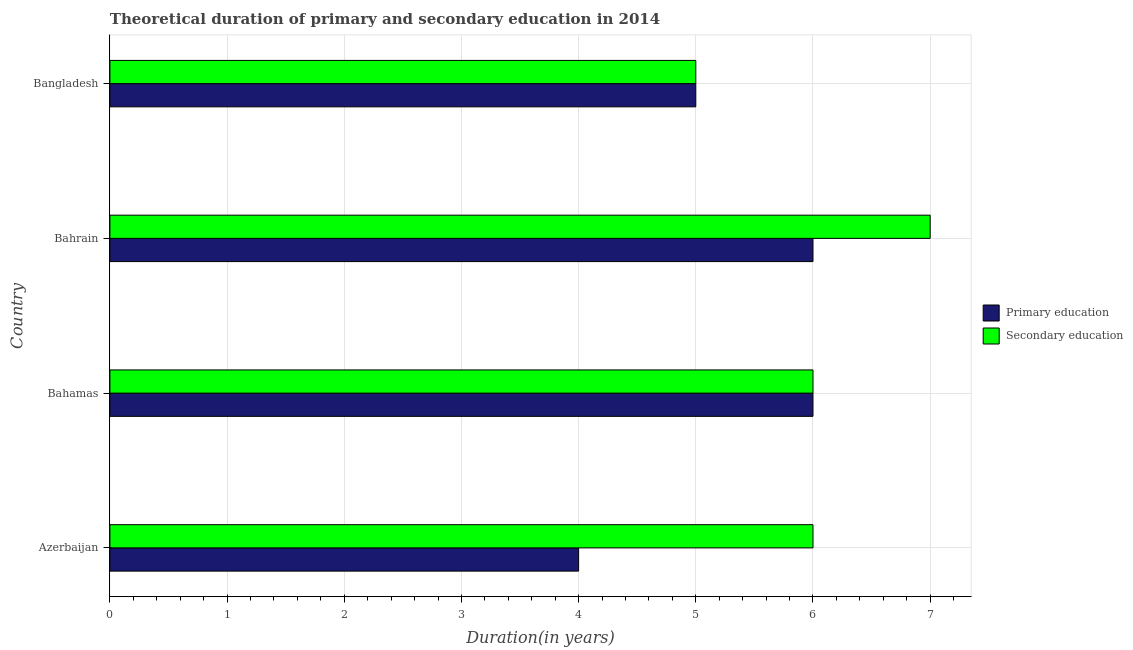How many different coloured bars are there?
Ensure brevity in your answer.  2. How many groups of bars are there?
Your answer should be compact. 4. Are the number of bars on each tick of the Y-axis equal?
Your answer should be compact. Yes. How many bars are there on the 2nd tick from the bottom?
Your answer should be compact. 2. What is the label of the 2nd group of bars from the top?
Offer a terse response. Bahrain. What is the duration of primary education in Bangladesh?
Your response must be concise. 5. Across all countries, what is the maximum duration of secondary education?
Your answer should be very brief. 7. Across all countries, what is the minimum duration of primary education?
Ensure brevity in your answer.  4. In which country was the duration of secondary education maximum?
Your response must be concise. Bahrain. In which country was the duration of primary education minimum?
Your answer should be compact. Azerbaijan. What is the total duration of secondary education in the graph?
Your response must be concise. 24. What is the difference between the duration of primary education in Bahamas and that in Bangladesh?
Your answer should be very brief. 1. What is the difference between the duration of primary education in Bahrain and the duration of secondary education in Bahamas?
Provide a short and direct response. 0. What is the average duration of primary education per country?
Provide a succinct answer. 5.25. In how many countries, is the duration of primary education greater than 0.4 years?
Keep it short and to the point. 4. What is the difference between the highest and the second highest duration of primary education?
Provide a short and direct response. 0. What is the difference between the highest and the lowest duration of secondary education?
Provide a short and direct response. 2. In how many countries, is the duration of secondary education greater than the average duration of secondary education taken over all countries?
Give a very brief answer. 1. Is the sum of the duration of secondary education in Bahamas and Bahrain greater than the maximum duration of primary education across all countries?
Keep it short and to the point. Yes. What does the 1st bar from the top in Azerbaijan represents?
Keep it short and to the point. Secondary education. What is the difference between two consecutive major ticks on the X-axis?
Make the answer very short. 1. Are the values on the major ticks of X-axis written in scientific E-notation?
Give a very brief answer. No. Does the graph contain grids?
Keep it short and to the point. Yes. Where does the legend appear in the graph?
Offer a terse response. Center right. How many legend labels are there?
Give a very brief answer. 2. What is the title of the graph?
Offer a very short reply. Theoretical duration of primary and secondary education in 2014. Does "Canada" appear as one of the legend labels in the graph?
Provide a short and direct response. No. What is the label or title of the X-axis?
Keep it short and to the point. Duration(in years). What is the label or title of the Y-axis?
Your answer should be very brief. Country. What is the Duration(in years) in Primary education in Azerbaijan?
Provide a short and direct response. 4. What is the Duration(in years) of Primary education in Bahamas?
Keep it short and to the point. 6. What is the Duration(in years) in Secondary education in Bahrain?
Your answer should be very brief. 7. Across all countries, what is the maximum Duration(in years) of Primary education?
Offer a terse response. 6. Across all countries, what is the minimum Duration(in years) in Primary education?
Give a very brief answer. 4. What is the total Duration(in years) in Primary education in the graph?
Keep it short and to the point. 21. What is the difference between the Duration(in years) of Primary education in Azerbaijan and that in Bahamas?
Offer a terse response. -2. What is the difference between the Duration(in years) in Secondary education in Azerbaijan and that in Bahamas?
Your answer should be compact. 0. What is the difference between the Duration(in years) of Primary education in Azerbaijan and that in Bahrain?
Ensure brevity in your answer.  -2. What is the difference between the Duration(in years) of Secondary education in Azerbaijan and that in Bahrain?
Offer a very short reply. -1. What is the difference between the Duration(in years) in Secondary education in Azerbaijan and that in Bangladesh?
Make the answer very short. 1. What is the difference between the Duration(in years) in Primary education in Bahamas and that in Bahrain?
Make the answer very short. 0. What is the difference between the Duration(in years) in Secondary education in Bahamas and that in Bahrain?
Make the answer very short. -1. What is the difference between the Duration(in years) in Primary education in Bahamas and that in Bangladesh?
Provide a succinct answer. 1. What is the difference between the Duration(in years) in Secondary education in Bahrain and that in Bangladesh?
Make the answer very short. 2. What is the difference between the Duration(in years) of Primary education in Bahamas and the Duration(in years) of Secondary education in Bahrain?
Your answer should be compact. -1. What is the difference between the Duration(in years) in Primary education in Bahamas and the Duration(in years) in Secondary education in Bangladesh?
Make the answer very short. 1. What is the difference between the Duration(in years) of Primary education in Bahrain and the Duration(in years) of Secondary education in Bangladesh?
Make the answer very short. 1. What is the average Duration(in years) in Primary education per country?
Provide a short and direct response. 5.25. What is the average Duration(in years) of Secondary education per country?
Provide a short and direct response. 6. What is the difference between the Duration(in years) of Primary education and Duration(in years) of Secondary education in Azerbaijan?
Offer a very short reply. -2. What is the difference between the Duration(in years) of Primary education and Duration(in years) of Secondary education in Bahamas?
Provide a short and direct response. 0. What is the difference between the Duration(in years) of Primary education and Duration(in years) of Secondary education in Bangladesh?
Your answer should be compact. 0. What is the ratio of the Duration(in years) of Primary education in Azerbaijan to that in Bahamas?
Provide a succinct answer. 0.67. What is the ratio of the Duration(in years) in Secondary education in Azerbaijan to that in Bahamas?
Your answer should be compact. 1. What is the ratio of the Duration(in years) of Primary education in Azerbaijan to that in Bahrain?
Make the answer very short. 0.67. What is the ratio of the Duration(in years) in Secondary education in Azerbaijan to that in Bangladesh?
Your answer should be compact. 1.2. What is the ratio of the Duration(in years) of Secondary education in Bahamas to that in Bahrain?
Provide a succinct answer. 0.86. What is the ratio of the Duration(in years) of Primary education in Bahamas to that in Bangladesh?
Provide a succinct answer. 1.2. What is the ratio of the Duration(in years) in Secondary education in Bahamas to that in Bangladesh?
Keep it short and to the point. 1.2. What is the ratio of the Duration(in years) in Secondary education in Bahrain to that in Bangladesh?
Make the answer very short. 1.4. What is the difference between the highest and the lowest Duration(in years) in Primary education?
Provide a succinct answer. 2. What is the difference between the highest and the lowest Duration(in years) in Secondary education?
Make the answer very short. 2. 